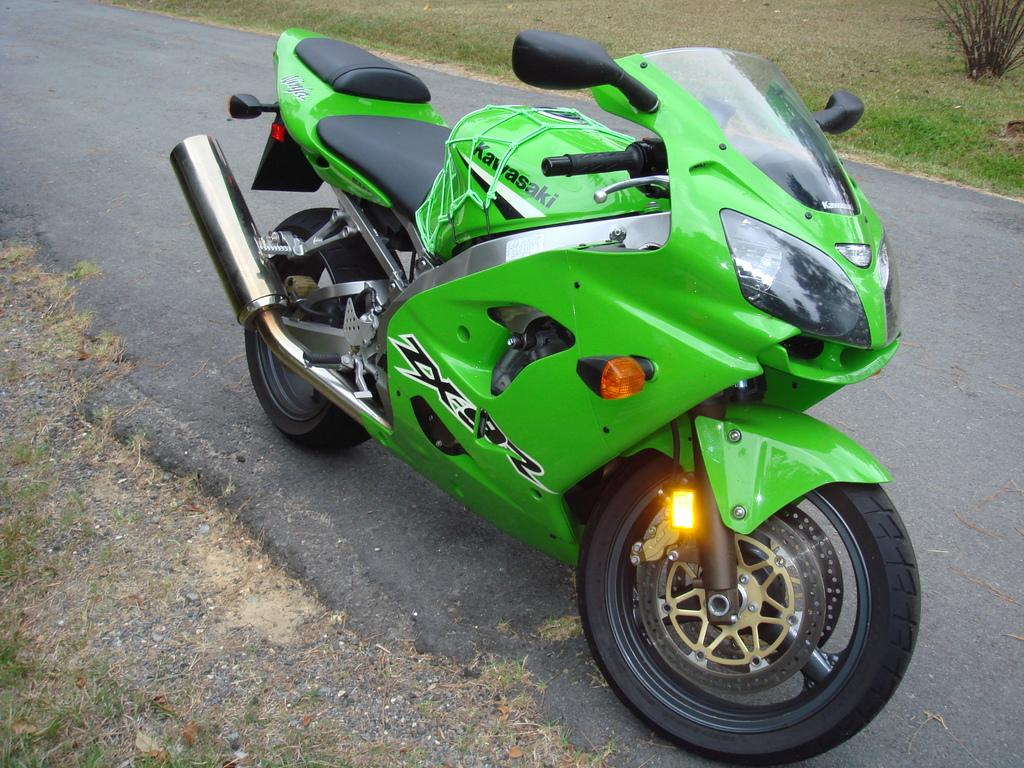What type of vehicle is in the image? There is a green motorbike in the image. Where is the motorbike located? The motorbike is on a road. What type of vegetation can be seen in the image? There is dried grass and a plant in the image. Can you see the fang of the snake in the image? There is no snake or fang present in the image. What type of cactus is growing on the side of the road in the image? There is no cactus mentioned or visible in the image. 